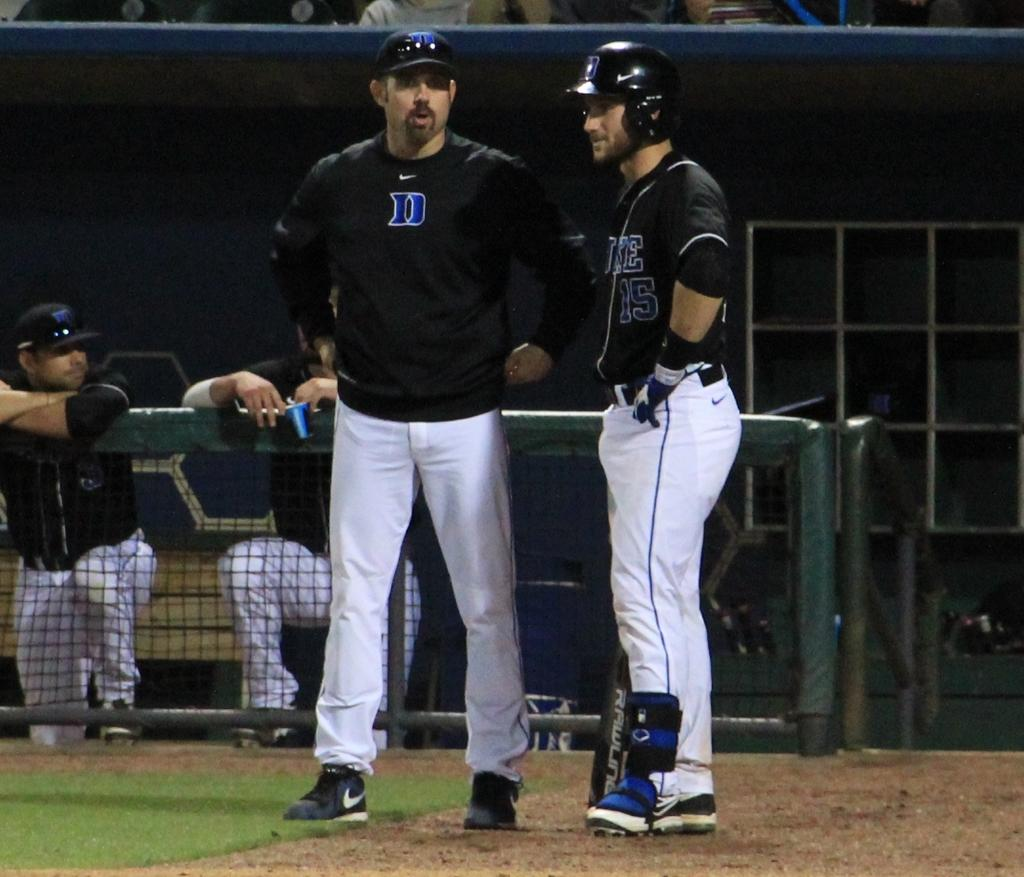<image>
Offer a succinct explanation of the picture presented. Baseball player wearing a black jersey with the number 15 talking to another player. 